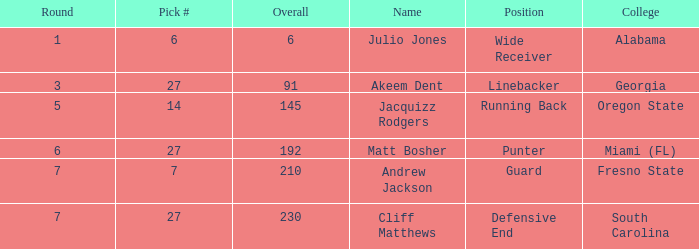What was the maximum draft pick number for akeem dent with an overall under 91? None. 